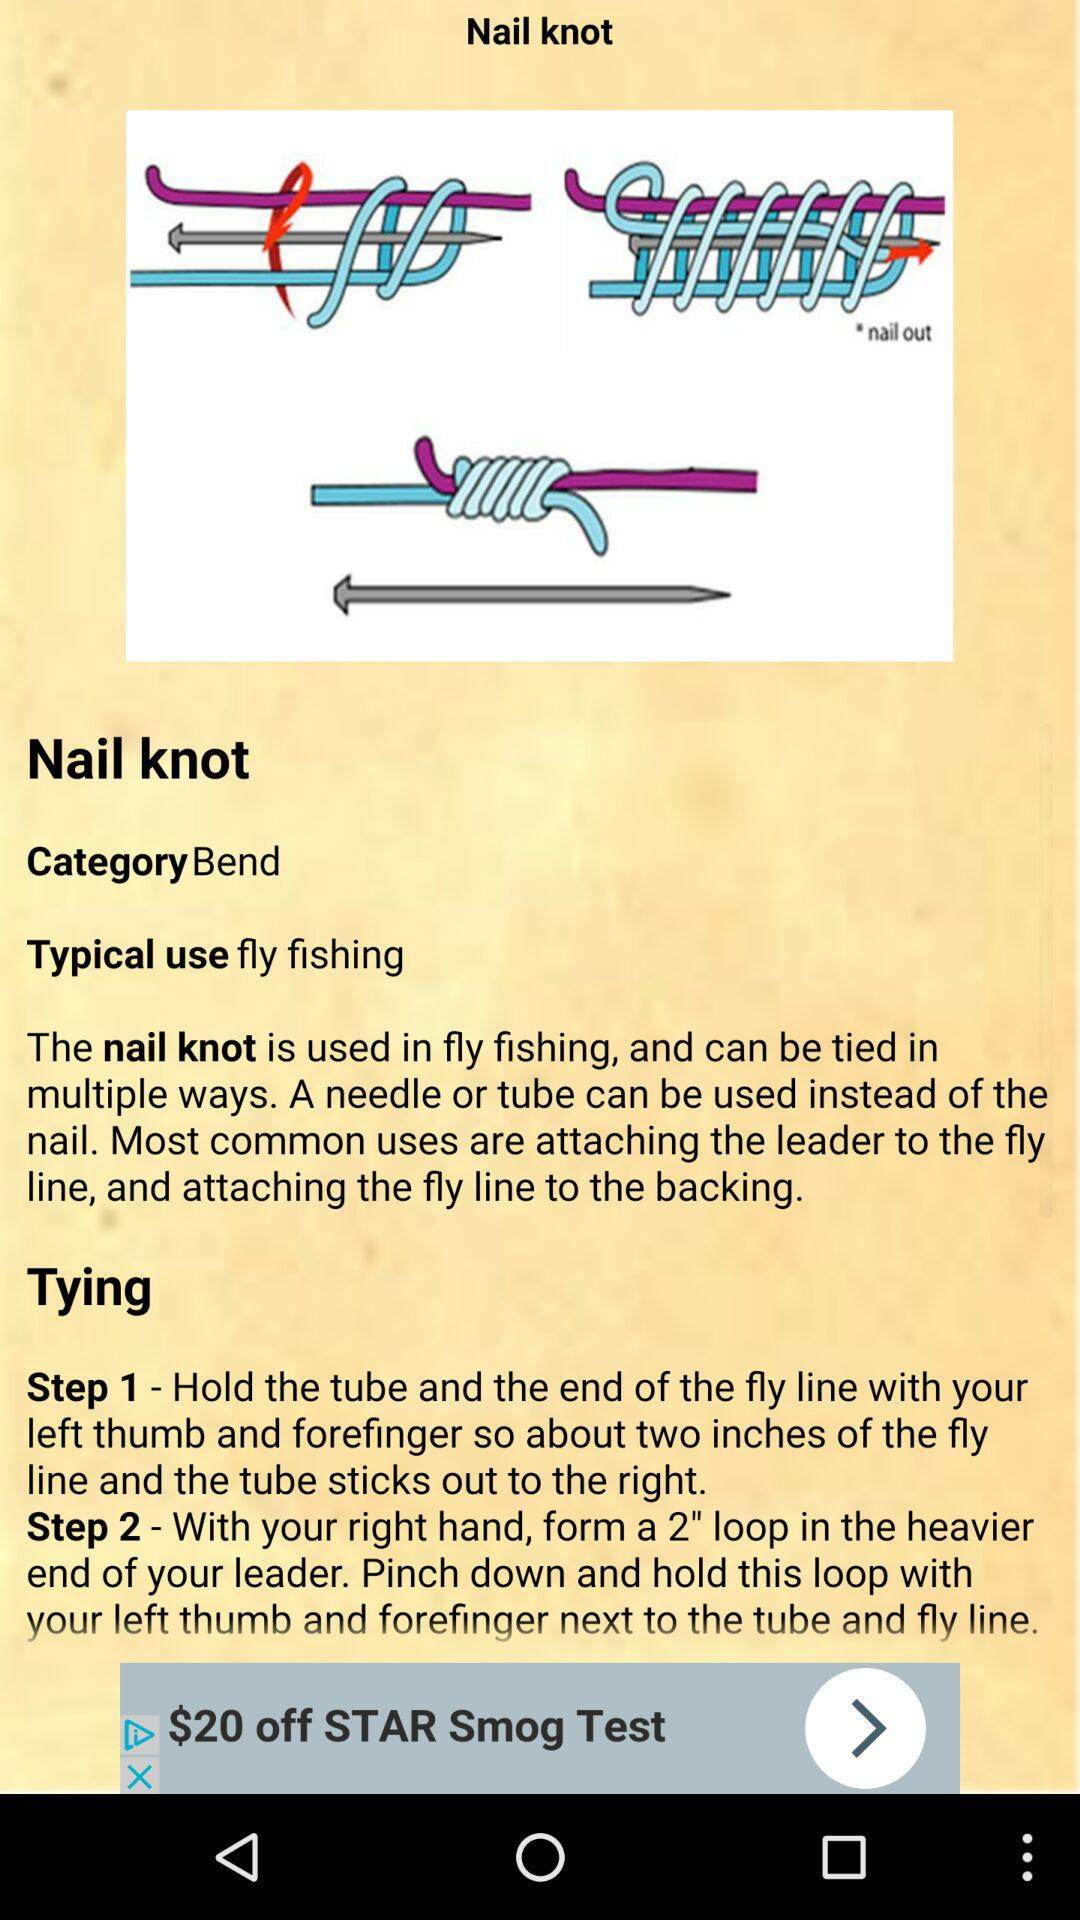How many steps are there in the tying instructions?
Answer the question using a single word or phrase. 2 